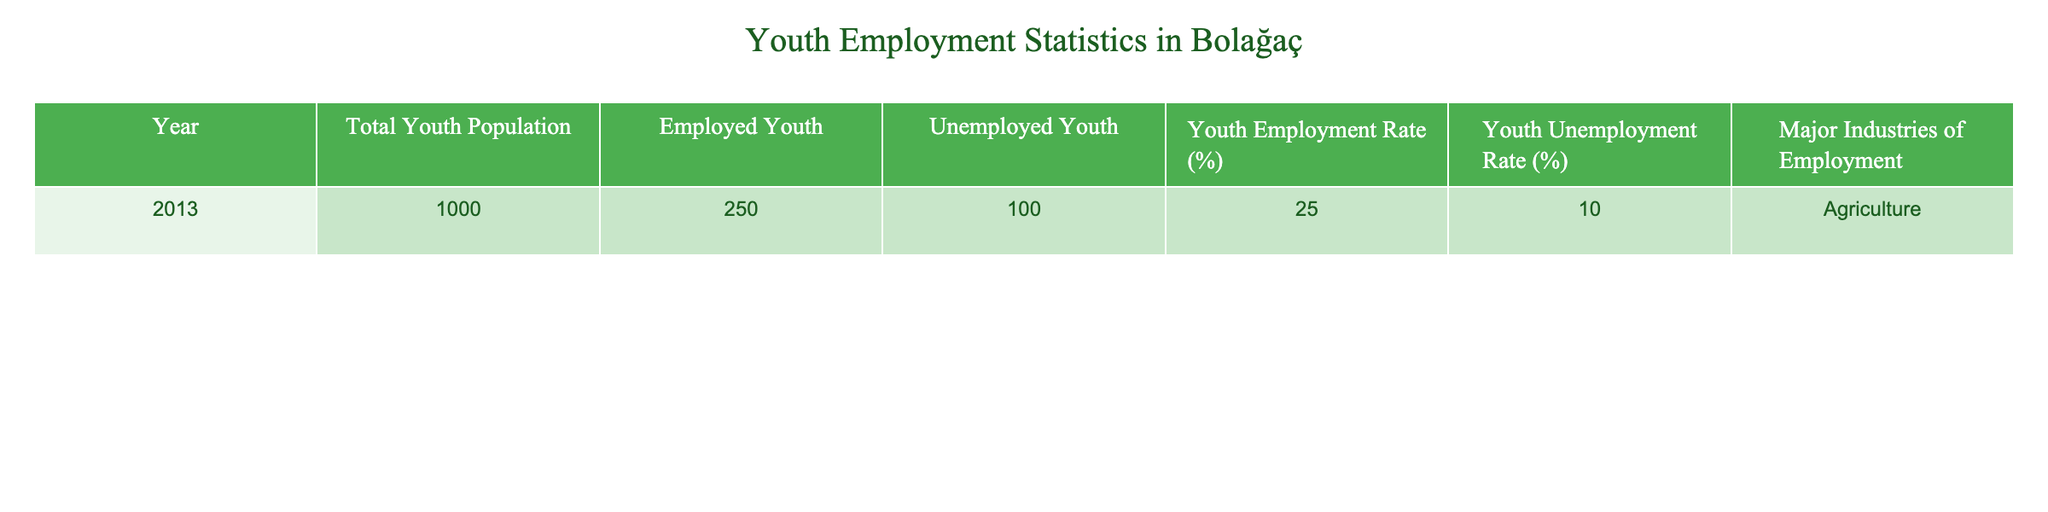What is the total youth population in Bolağaç for the year 2013? The table shows that in 2013, the total youth population is listed as 1000.
Answer: 1000 How many employed youth are there in 2013? According to the table, the number of employed youth in 2013 is given as 250.
Answer: 250 What is the youth employment rate for 2013? The table indicates that the youth employment rate for 2013 is 25.0%.
Answer: 25.0% Is the youth unemployment rate greater than 10% in 2013? The table shows that the youth unemployment rate is 10.0%, which is not greater than 10%. Therefore, the answer is no.
Answer: No What is the difference between the number of unemployed youth and the number of employed youth in 2013? The table shows that there are 100 unemployed youth and 250 employed youth. The difference is calculated as 250 - 100 = 150.
Answer: 150 What percentage of the total youth population in 2013 is employed? To find the percentage of employed youth, we take the number of employed youth (250) and divide it by the total youth population (1000), then multiply by 100. This gives us (250/1000) * 100 = 25.0%.
Answer: 25.0% Which major industry employs the youth in Bolağaç according to the table? The table specifies that the major industry of employment for youth in Bolağaç is Agriculture.
Answer: Agriculture If the number of unemployed youth were to decrease to 75, what would the new youth unemployment rate be? To calculate the new unemployment rate, we would subtract the new number of unemployed youth (75) from the total youth population (1000), giving us 925 employed. The new unemployment rate is calculated as (75/1000) * 100 = 7.5%.
Answer: 7.5% How many more unemployed youth are there than employed youth in 2013? The number of unemployed youth is 100 and the number of employed youth is 250. The difference shows that there are 250 - 100 = 150 more employed youth than unemployed youth.
Answer: 150 